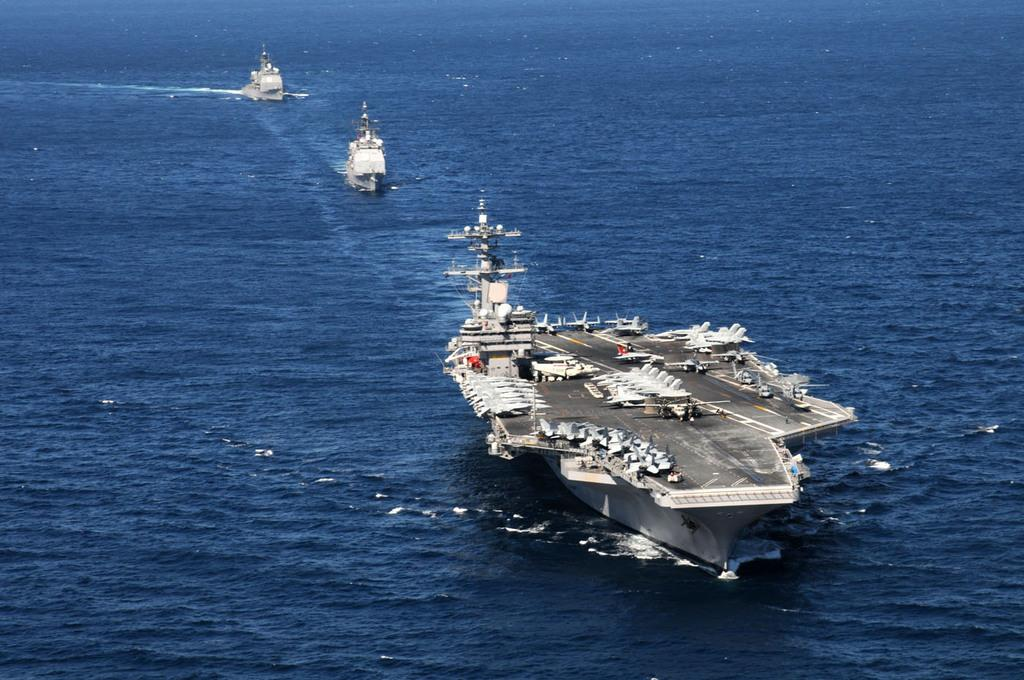How many boats can be seen in the image? There are three boats in the image. Where are the boats located? The boats are on the surface of the sea. What type of house is visible in the image? There is no house present in the image; it features three boats on the surface of the sea. How much rice can be seen in the image? There is no rice present in the image. 